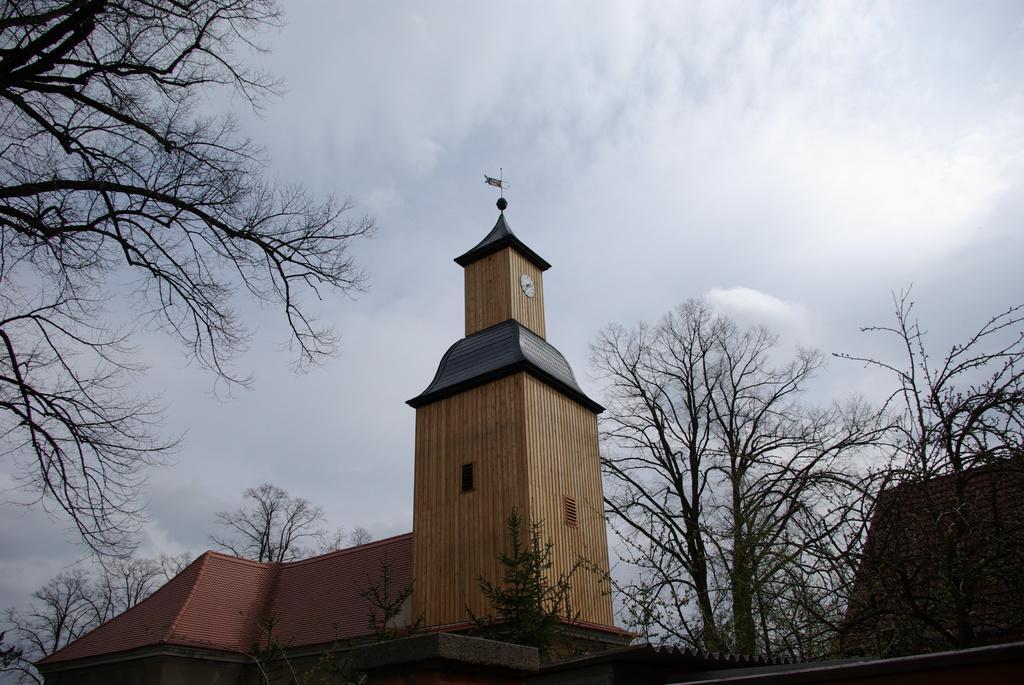Could you give a brief overview of what you see in this image? In this picture we can observe a building which is in cream and maroon colors. There are dried trees. In the background there is a sky with some clouds. 